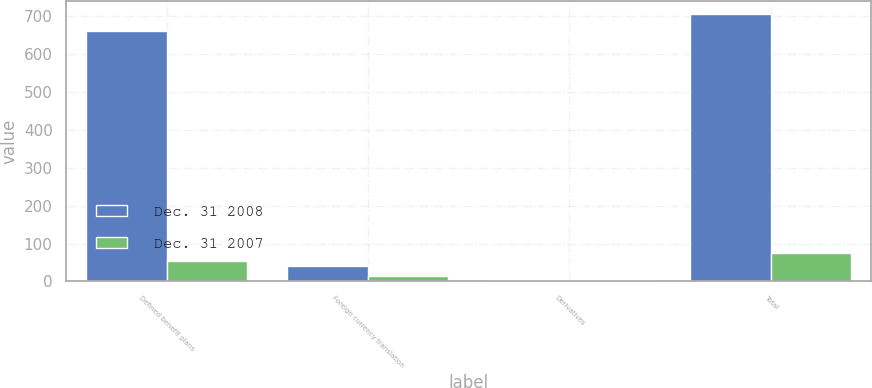<chart> <loc_0><loc_0><loc_500><loc_500><stacked_bar_chart><ecel><fcel>Defined benefit plans<fcel>Foreign currency translation<fcel>Derivatives<fcel>Total<nl><fcel>Dec. 31 2008<fcel>659<fcel>41<fcel>4<fcel>704<nl><fcel>Dec. 31 2007<fcel>55<fcel>15<fcel>4<fcel>74<nl></chart> 